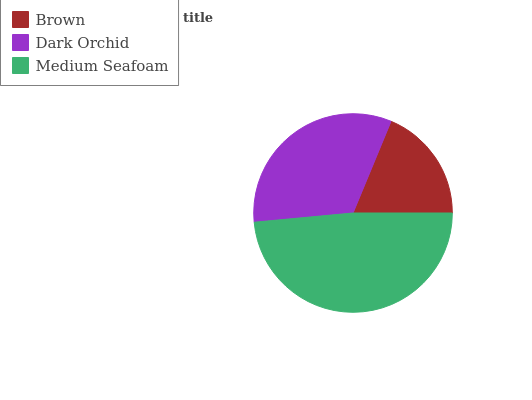Is Brown the minimum?
Answer yes or no. Yes. Is Medium Seafoam the maximum?
Answer yes or no. Yes. Is Dark Orchid the minimum?
Answer yes or no. No. Is Dark Orchid the maximum?
Answer yes or no. No. Is Dark Orchid greater than Brown?
Answer yes or no. Yes. Is Brown less than Dark Orchid?
Answer yes or no. Yes. Is Brown greater than Dark Orchid?
Answer yes or no. No. Is Dark Orchid less than Brown?
Answer yes or no. No. Is Dark Orchid the high median?
Answer yes or no. Yes. Is Dark Orchid the low median?
Answer yes or no. Yes. Is Brown the high median?
Answer yes or no. No. Is Medium Seafoam the low median?
Answer yes or no. No. 